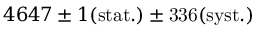Convert formula to latex. <formula><loc_0><loc_0><loc_500><loc_500>4 6 4 7 \pm 1 { ( s t a t . ) } \pm 3 3 6 \mathrm { ( s y s t . ) }</formula> 